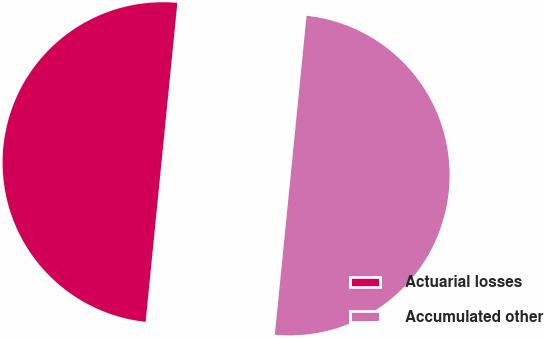<chart> <loc_0><loc_0><loc_500><loc_500><pie_chart><fcel>Actuarial losses<fcel>Accumulated other<nl><fcel>50.0%<fcel>50.0%<nl></chart> 